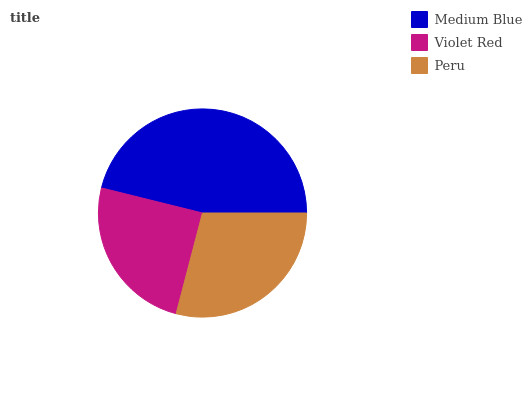Is Violet Red the minimum?
Answer yes or no. Yes. Is Medium Blue the maximum?
Answer yes or no. Yes. Is Peru the minimum?
Answer yes or no. No. Is Peru the maximum?
Answer yes or no. No. Is Peru greater than Violet Red?
Answer yes or no. Yes. Is Violet Red less than Peru?
Answer yes or no. Yes. Is Violet Red greater than Peru?
Answer yes or no. No. Is Peru less than Violet Red?
Answer yes or no. No. Is Peru the high median?
Answer yes or no. Yes. Is Peru the low median?
Answer yes or no. Yes. Is Violet Red the high median?
Answer yes or no. No. Is Violet Red the low median?
Answer yes or no. No. 